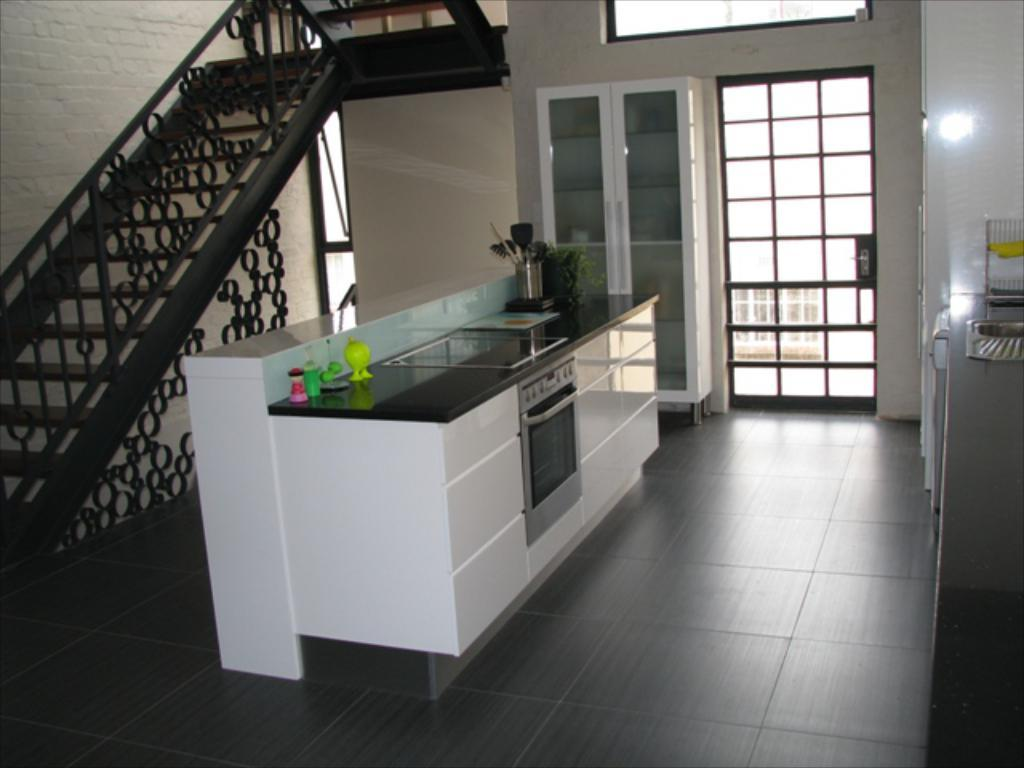What is located in the foreground of the image? There is a cabinet, bottles, and a houseplant in the foreground of the image. What is visible in the background of the image? There is a cupboard, a window, a wall, and a staircase in the background of the image. What type of room might the image be taken in? The image is likely taken in a room, as it contains furniture and household items. Can you see any elbows in the image? There are no elbows visible in the image. What type of mist is present in the room in the image? There is no mist present in the room in the image. 